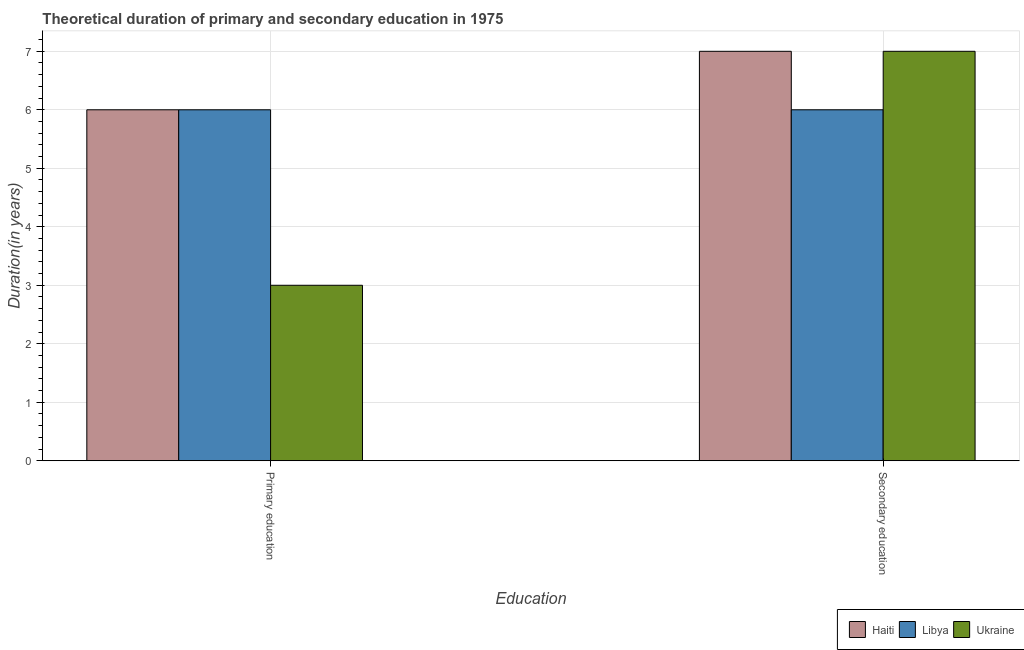How many groups of bars are there?
Offer a very short reply. 2. Are the number of bars per tick equal to the number of legend labels?
Provide a succinct answer. Yes. How many bars are there on the 2nd tick from the right?
Your answer should be compact. 3. What is the label of the 2nd group of bars from the left?
Give a very brief answer. Secondary education. Across all countries, what is the minimum duration of secondary education?
Offer a terse response. 6. In which country was the duration of secondary education maximum?
Offer a very short reply. Haiti. In which country was the duration of primary education minimum?
Offer a terse response. Ukraine. What is the total duration of primary education in the graph?
Offer a very short reply. 15. What is the difference between the duration of primary education in Libya and that in Ukraine?
Make the answer very short. 3. What is the difference between the duration of primary education in Ukraine and the duration of secondary education in Libya?
Your response must be concise. -3. What is the average duration of primary education per country?
Your answer should be very brief. 5. What is the difference between the duration of primary education and duration of secondary education in Libya?
Ensure brevity in your answer.  0. What is the ratio of the duration of primary education in Libya to that in Ukraine?
Your response must be concise. 2. In how many countries, is the duration of primary education greater than the average duration of primary education taken over all countries?
Your response must be concise. 2. What does the 3rd bar from the left in Secondary education represents?
Your answer should be very brief. Ukraine. What does the 3rd bar from the right in Primary education represents?
Give a very brief answer. Haiti. How many countries are there in the graph?
Keep it short and to the point. 3. What is the difference between two consecutive major ticks on the Y-axis?
Your answer should be very brief. 1. Are the values on the major ticks of Y-axis written in scientific E-notation?
Keep it short and to the point. No. Does the graph contain any zero values?
Ensure brevity in your answer.  No. Where does the legend appear in the graph?
Provide a succinct answer. Bottom right. How many legend labels are there?
Offer a terse response. 3. What is the title of the graph?
Give a very brief answer. Theoretical duration of primary and secondary education in 1975. What is the label or title of the X-axis?
Give a very brief answer. Education. What is the label or title of the Y-axis?
Your response must be concise. Duration(in years). What is the Duration(in years) in Ukraine in Primary education?
Make the answer very short. 3. What is the Duration(in years) in Haiti in Secondary education?
Your response must be concise. 7. What is the Duration(in years) in Libya in Secondary education?
Your response must be concise. 6. What is the Duration(in years) in Ukraine in Secondary education?
Your response must be concise. 7. Across all Education, what is the maximum Duration(in years) of Libya?
Your answer should be compact. 6. Across all Education, what is the minimum Duration(in years) of Libya?
Your response must be concise. 6. What is the total Duration(in years) in Haiti in the graph?
Offer a very short reply. 13. What is the total Duration(in years) of Libya in the graph?
Make the answer very short. 12. What is the difference between the Duration(in years) of Haiti in Primary education and the Duration(in years) of Ukraine in Secondary education?
Your answer should be very brief. -1. What is the average Duration(in years) of Haiti per Education?
Offer a very short reply. 6.5. What is the average Duration(in years) in Libya per Education?
Offer a terse response. 6. What is the difference between the Duration(in years) of Haiti and Duration(in years) of Ukraine in Primary education?
Your answer should be very brief. 3. What is the difference between the Duration(in years) of Libya and Duration(in years) of Ukraine in Primary education?
Offer a very short reply. 3. What is the difference between the Duration(in years) of Haiti and Duration(in years) of Libya in Secondary education?
Provide a short and direct response. 1. What is the difference between the Duration(in years) of Haiti and Duration(in years) of Ukraine in Secondary education?
Provide a succinct answer. 0. What is the ratio of the Duration(in years) of Haiti in Primary education to that in Secondary education?
Your answer should be compact. 0.86. What is the ratio of the Duration(in years) of Ukraine in Primary education to that in Secondary education?
Your response must be concise. 0.43. What is the difference between the highest and the second highest Duration(in years) in Haiti?
Keep it short and to the point. 1. What is the difference between the highest and the second highest Duration(in years) in Ukraine?
Your answer should be compact. 4. What is the difference between the highest and the lowest Duration(in years) in Ukraine?
Your answer should be compact. 4. 